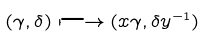Convert formula to latex. <formula><loc_0><loc_0><loc_500><loc_500>( \gamma , \delta ) \longmapsto ( x \gamma , \delta y ^ { - 1 } )</formula> 